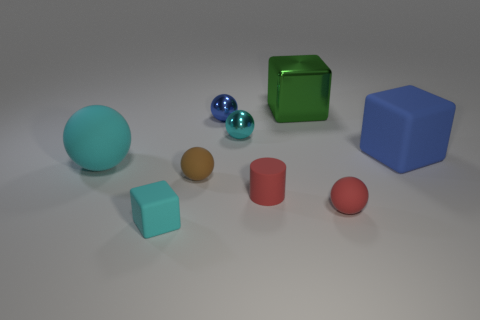The cyan rubber object that is behind the tiny brown thing has what shape?
Make the answer very short. Sphere. Does the matte cube on the left side of the large matte cube have the same color as the tiny thing behind the small cyan sphere?
Offer a terse response. No. There is a thing that is the same color as the small cylinder; what size is it?
Offer a very short reply. Small. Is there a brown matte cube?
Offer a very short reply. No. The big object that is behind the blue object to the right of the shiny thing right of the small cylinder is what shape?
Your response must be concise. Cube. There is a large cyan thing; how many small red rubber balls are to the left of it?
Your answer should be compact. 0. Is the material of the cube that is in front of the big ball the same as the brown sphere?
Provide a short and direct response. Yes. How many other objects are there of the same shape as the tiny cyan shiny thing?
Ensure brevity in your answer.  4. There is a tiny cyan thing behind the object in front of the red ball; how many blue rubber objects are left of it?
Give a very brief answer. 0. There is a large block that is left of the tiny red matte ball; what color is it?
Your answer should be compact. Green. 